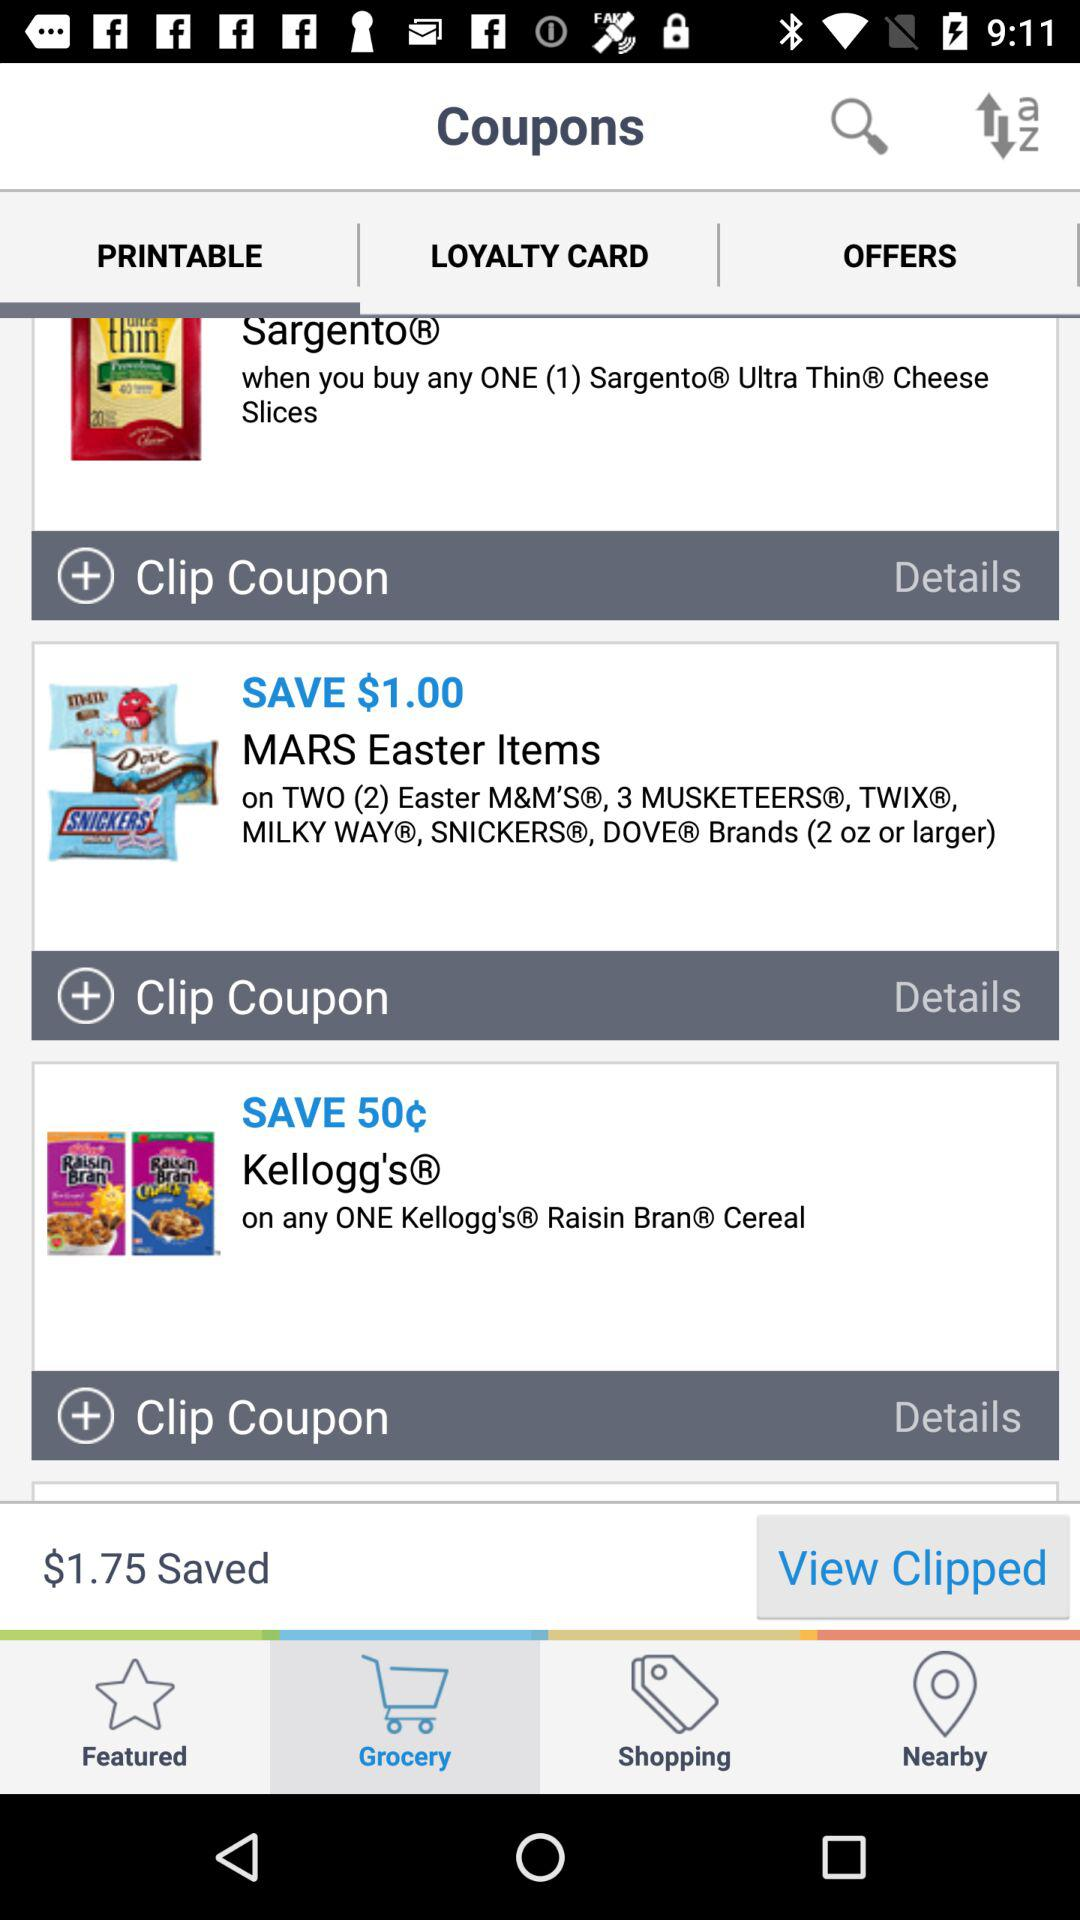Which tab has been selected? The selected tabs are "Grocery" and "PRINTABLE". 